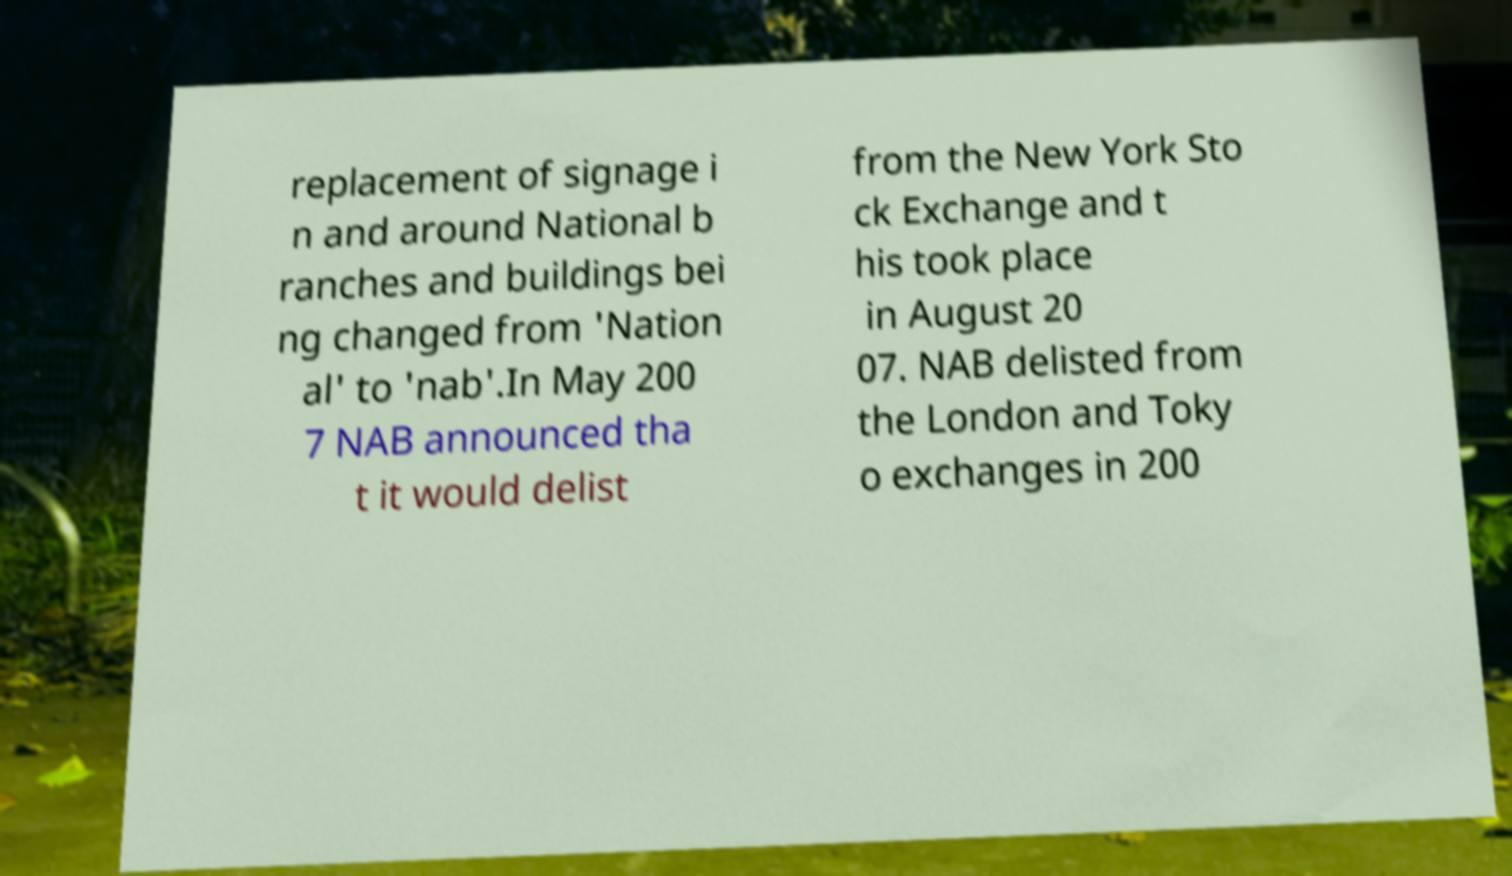Can you read and provide the text displayed in the image?This photo seems to have some interesting text. Can you extract and type it out for me? replacement of signage i n and around National b ranches and buildings bei ng changed from 'Nation al' to 'nab'.In May 200 7 NAB announced tha t it would delist from the New York Sto ck Exchange and t his took place in August 20 07. NAB delisted from the London and Toky o exchanges in 200 